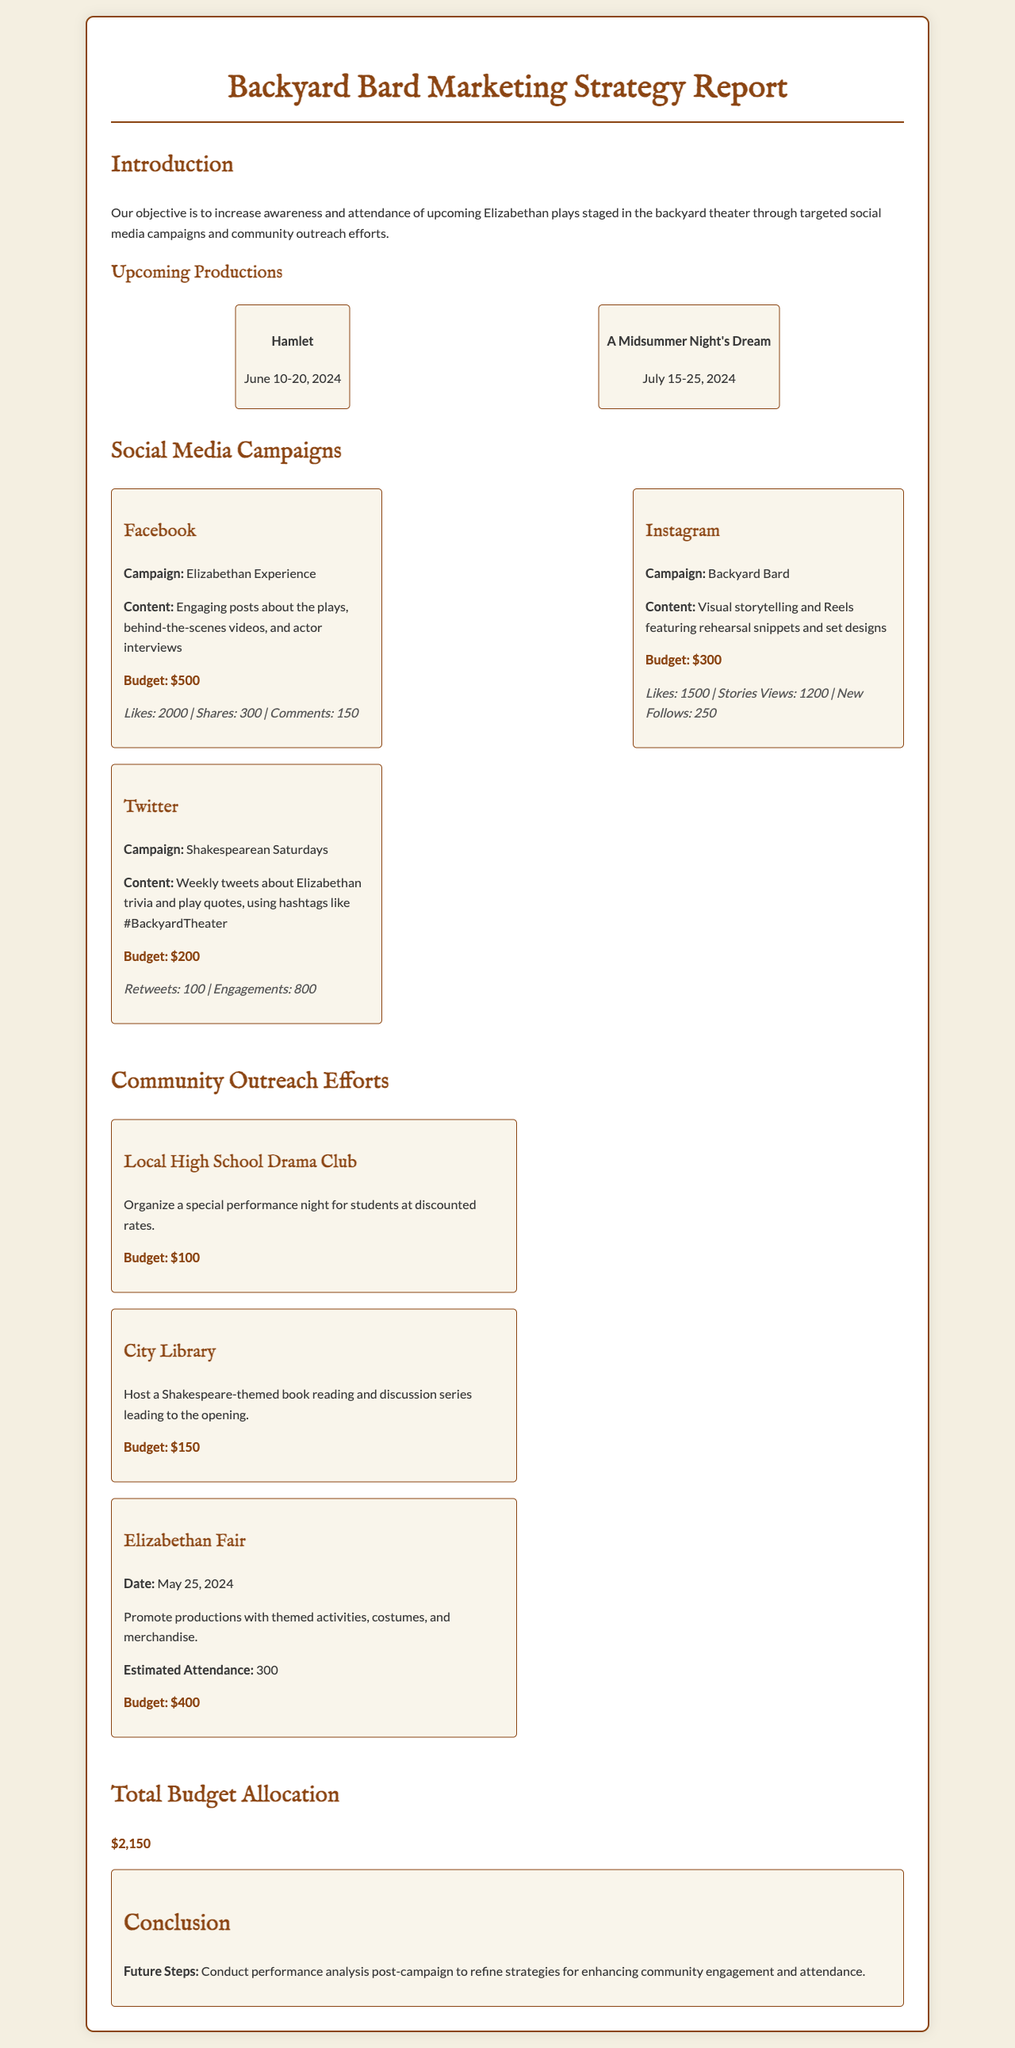What are the upcoming production titles? The document lists two upcoming productions, which are "Hamlet" and "A Midsummer Night's Dream."
Answer: Hamlet, A Midsummer Night's Dream What is the budget for the Facebook campaign? The budget for the Facebook campaign is explicitly stated in the section detailing social media campaigns.
Answer: $500 How many likes did the Instagram campaign receive? The number of likes for the Instagram campaign is mentioned in the engagement metrics.
Answer: 1500 What is the date of the Elizabethan Fair? The date for the Elizabethan Fair is specifically noted in the community outreach section.
Answer: May 25, 2024 What is the total budget allocation? The total budget allocation is summarized in the document, providing a complete amount.
Answer: $2,150 What type of special performance is organized for the Local High School Drama Club? The document details the nature of the outreach effort for the Local High School Drama Club.
Answer: Discounted rates Which social media platform had the highest engagement according to the metrics? By comparing the metrics provided for each platform, it can be determined which had the highest engagement.
Answer: Facebook What community outreach effort involves a Shakespeare-themed book reading? The document describes the effort related to the City Library and its activities.
Answer: City Library What is the estimated attendance for the Elizabethan Fair? The estimated attendance for the Elizabethan Fair is stated in the community outreach efforts.
Answer: 300 